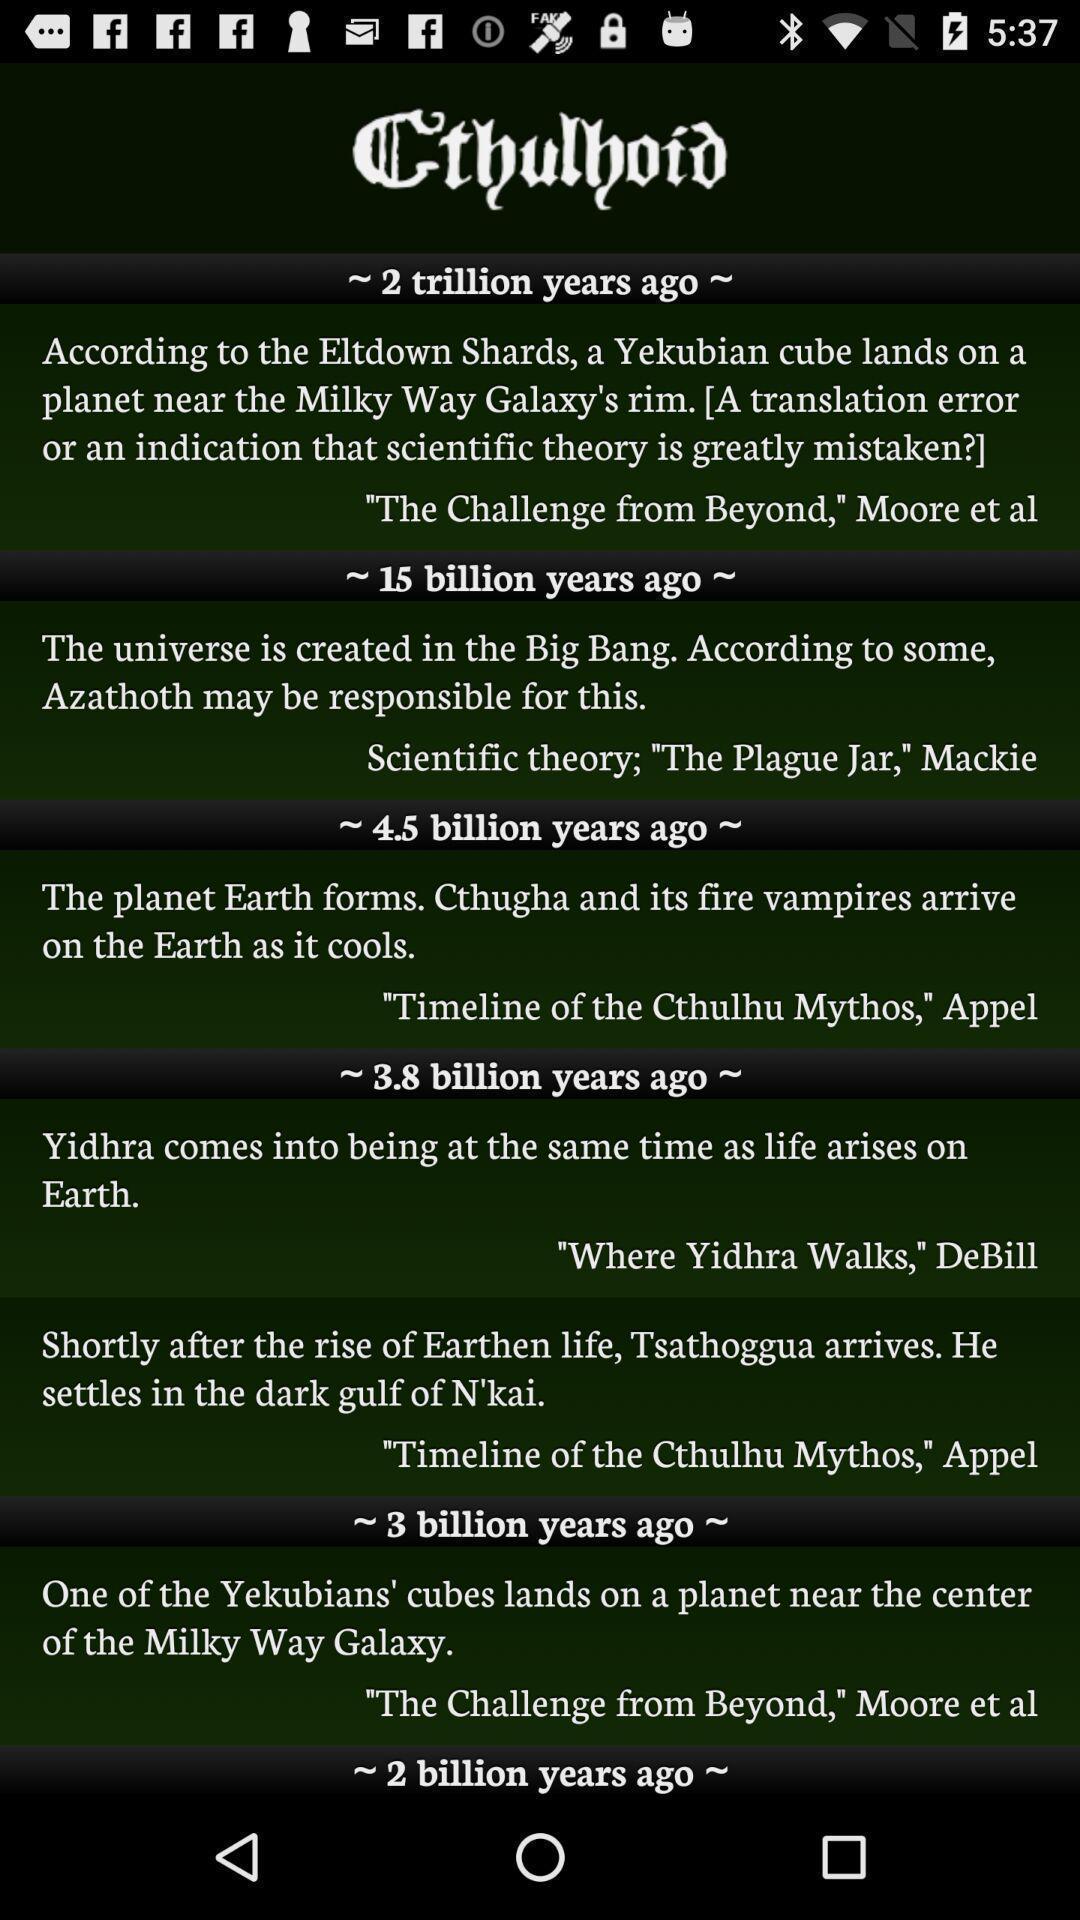Summarize the information in this screenshot. Page displaying the writings of an author. 